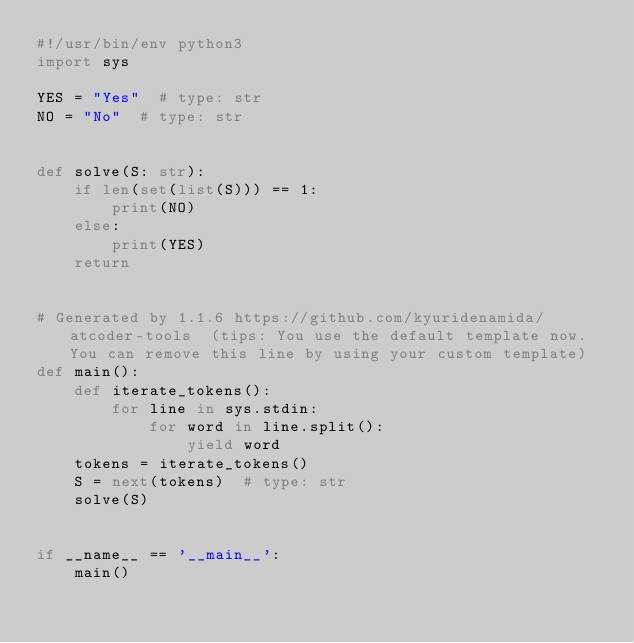<code> <loc_0><loc_0><loc_500><loc_500><_Python_>#!/usr/bin/env python3
import sys

YES = "Yes"  # type: str
NO = "No"  # type: str


def solve(S: str):
    if len(set(list(S))) == 1:
        print(NO)
    else:
        print(YES)
    return


# Generated by 1.1.6 https://github.com/kyuridenamida/atcoder-tools  (tips: You use the default template now. You can remove this line by using your custom template)
def main():
    def iterate_tokens():
        for line in sys.stdin:
            for word in line.split():
                yield word
    tokens = iterate_tokens()
    S = next(tokens)  # type: str
    solve(S)


if __name__ == '__main__':
    main()
</code> 